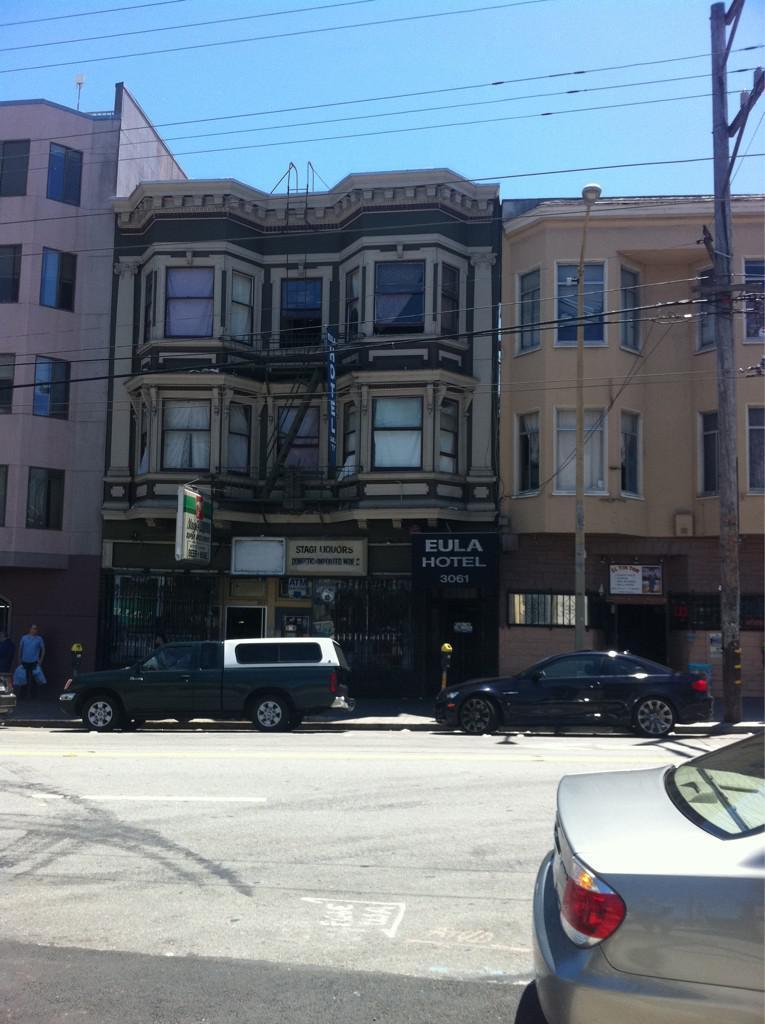In one or two sentences, can you explain what this image depicts? On the right side, there is a vehicle on the road. In the background, there are vehicles on the road, there is a pole which is having electric lines, there are buildings which are having glass windows and there is blue sky. 